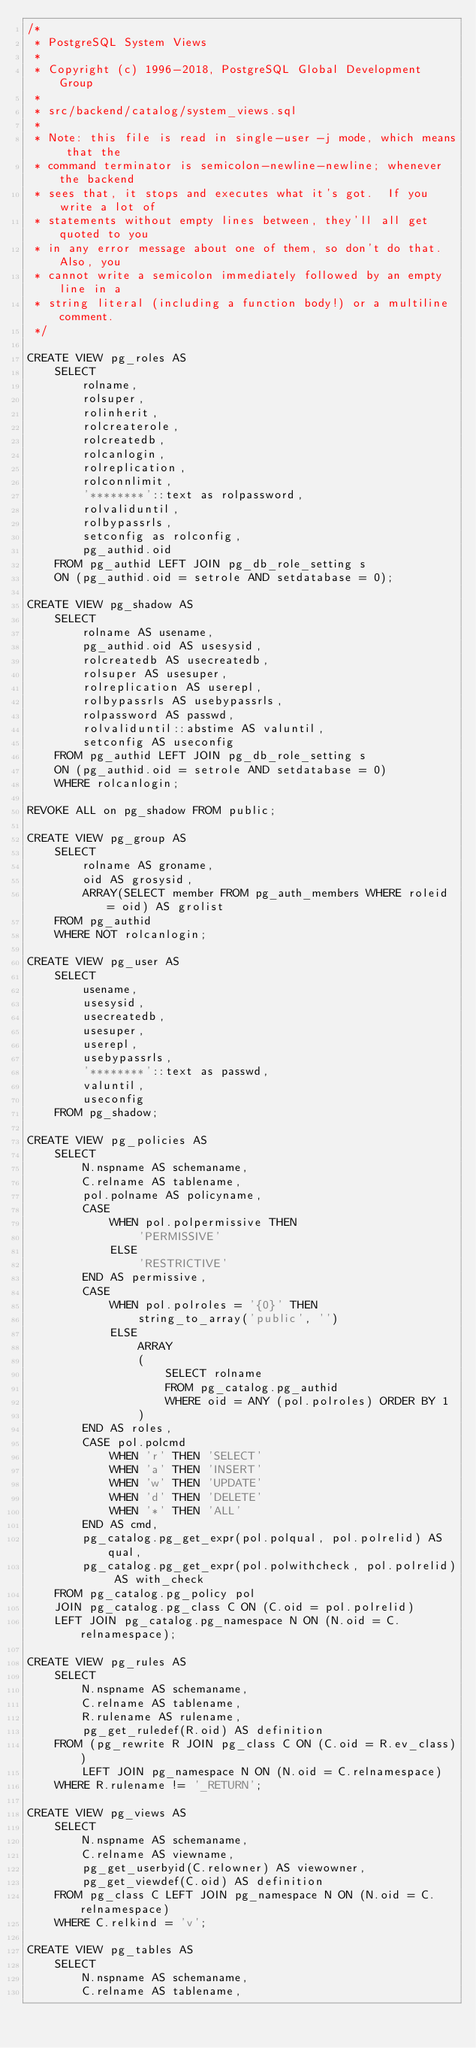<code> <loc_0><loc_0><loc_500><loc_500><_SQL_>/*
 * PostgreSQL System Views
 *
 * Copyright (c) 1996-2018, PostgreSQL Global Development Group
 *
 * src/backend/catalog/system_views.sql
 *
 * Note: this file is read in single-user -j mode, which means that the
 * command terminator is semicolon-newline-newline; whenever the backend
 * sees that, it stops and executes what it's got.  If you write a lot of
 * statements without empty lines between, they'll all get quoted to you
 * in any error message about one of them, so don't do that.  Also, you
 * cannot write a semicolon immediately followed by an empty line in a
 * string literal (including a function body!) or a multiline comment.
 */

CREATE VIEW pg_roles AS
    SELECT
        rolname,
        rolsuper,
        rolinherit,
        rolcreaterole,
        rolcreatedb,
        rolcanlogin,
        rolreplication,
        rolconnlimit,
        '********'::text as rolpassword,
        rolvaliduntil,
        rolbypassrls,
        setconfig as rolconfig,
        pg_authid.oid
    FROM pg_authid LEFT JOIN pg_db_role_setting s
    ON (pg_authid.oid = setrole AND setdatabase = 0);

CREATE VIEW pg_shadow AS
    SELECT
        rolname AS usename,
        pg_authid.oid AS usesysid,
        rolcreatedb AS usecreatedb,
        rolsuper AS usesuper,
        rolreplication AS userepl,
        rolbypassrls AS usebypassrls,
        rolpassword AS passwd,
        rolvaliduntil::abstime AS valuntil,
        setconfig AS useconfig
    FROM pg_authid LEFT JOIN pg_db_role_setting s
    ON (pg_authid.oid = setrole AND setdatabase = 0)
    WHERE rolcanlogin;

REVOKE ALL on pg_shadow FROM public;

CREATE VIEW pg_group AS
    SELECT
        rolname AS groname,
        oid AS grosysid,
        ARRAY(SELECT member FROM pg_auth_members WHERE roleid = oid) AS grolist
    FROM pg_authid
    WHERE NOT rolcanlogin;

CREATE VIEW pg_user AS
    SELECT
        usename,
        usesysid,
        usecreatedb,
        usesuper,
        userepl,
        usebypassrls,
        '********'::text as passwd,
        valuntil,
        useconfig
    FROM pg_shadow;

CREATE VIEW pg_policies AS
    SELECT
        N.nspname AS schemaname,
        C.relname AS tablename,
        pol.polname AS policyname,
        CASE
            WHEN pol.polpermissive THEN
                'PERMISSIVE'
            ELSE
                'RESTRICTIVE'
        END AS permissive,
        CASE
            WHEN pol.polroles = '{0}' THEN
                string_to_array('public', '')
            ELSE
                ARRAY
                (
                    SELECT rolname
                    FROM pg_catalog.pg_authid
                    WHERE oid = ANY (pol.polroles) ORDER BY 1
                )
        END AS roles,
        CASE pol.polcmd
            WHEN 'r' THEN 'SELECT'
            WHEN 'a' THEN 'INSERT'
            WHEN 'w' THEN 'UPDATE'
            WHEN 'd' THEN 'DELETE'
            WHEN '*' THEN 'ALL'
        END AS cmd,
        pg_catalog.pg_get_expr(pol.polqual, pol.polrelid) AS qual,
        pg_catalog.pg_get_expr(pol.polwithcheck, pol.polrelid) AS with_check
    FROM pg_catalog.pg_policy pol
    JOIN pg_catalog.pg_class C ON (C.oid = pol.polrelid)
    LEFT JOIN pg_catalog.pg_namespace N ON (N.oid = C.relnamespace);

CREATE VIEW pg_rules AS
    SELECT
        N.nspname AS schemaname,
        C.relname AS tablename,
        R.rulename AS rulename,
        pg_get_ruledef(R.oid) AS definition
    FROM (pg_rewrite R JOIN pg_class C ON (C.oid = R.ev_class))
        LEFT JOIN pg_namespace N ON (N.oid = C.relnamespace)
    WHERE R.rulename != '_RETURN';

CREATE VIEW pg_views AS
    SELECT
        N.nspname AS schemaname,
        C.relname AS viewname,
        pg_get_userbyid(C.relowner) AS viewowner,
        pg_get_viewdef(C.oid) AS definition
    FROM pg_class C LEFT JOIN pg_namespace N ON (N.oid = C.relnamespace)
    WHERE C.relkind = 'v';

CREATE VIEW pg_tables AS
    SELECT
        N.nspname AS schemaname,
        C.relname AS tablename,</code> 